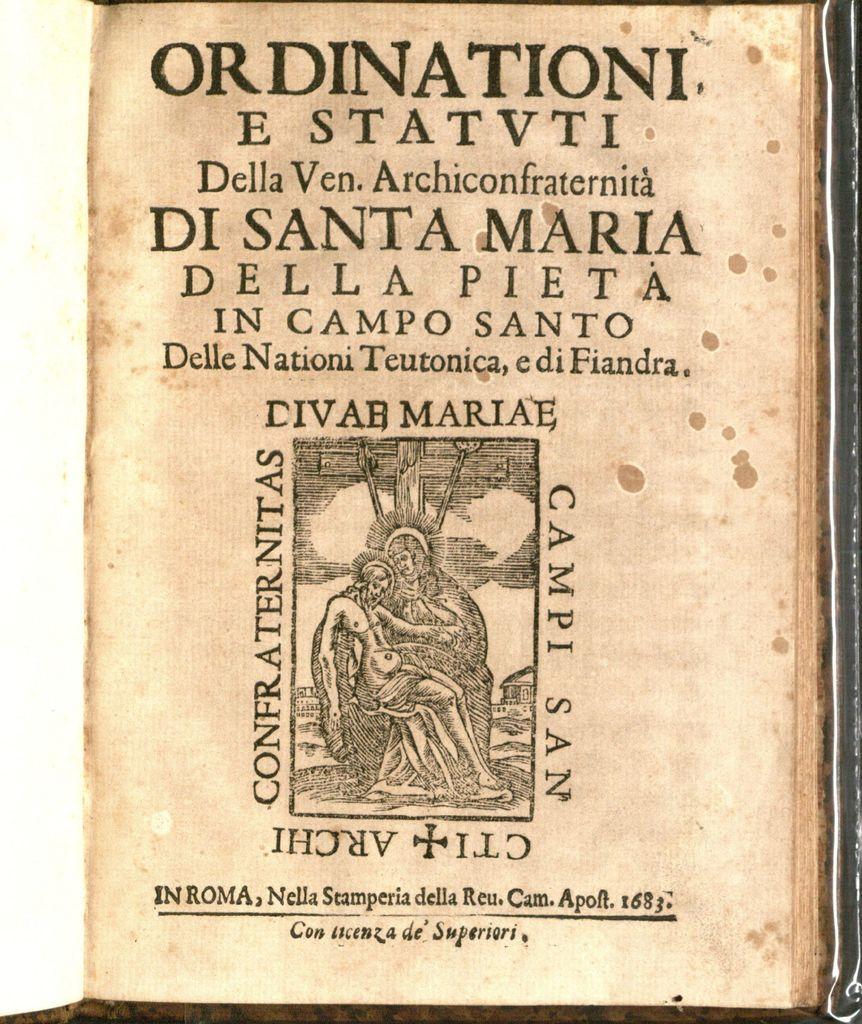What is the last word?
Your answer should be compact. Superiori. 